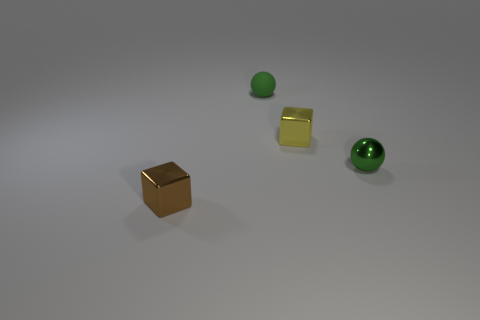Add 1 shiny things. How many objects exist? 5 Subtract 0 purple cubes. How many objects are left? 4 Subtract all small green balls. Subtract all tiny green metallic objects. How many objects are left? 1 Add 4 tiny green matte objects. How many tiny green matte objects are left? 5 Add 3 tiny brown metal cubes. How many tiny brown metal cubes exist? 4 